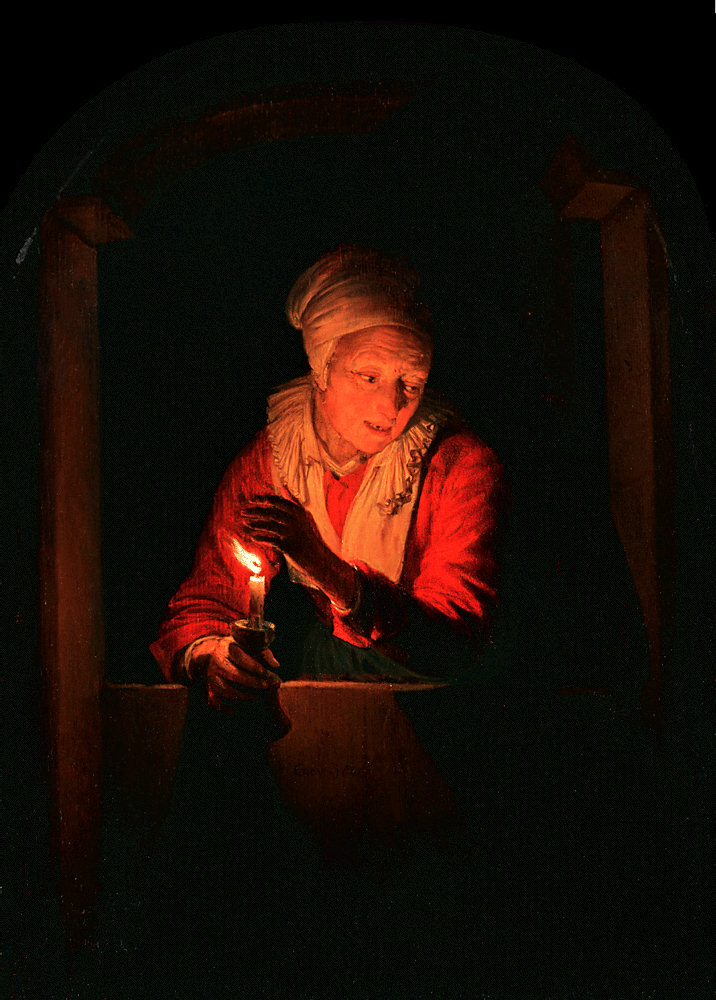Imagine this scene as the beginning of a fairytale. How would the story start? In a quaint village, nestled between rolling hills and ancient woods, there lived an elderly woman named Elda. Every night, she would sit by her window with a candle in hand, waiting for the magical hour when the moon would light up the night sky. Elda was the keeper of an age-old secret— a hidden path revealed only by the first glow of the moonlight, leading to a mystical forest where dreams and reality entwined. Little did she know, tonight was the night a young, curious wanderer would discover this secret and embark on an enchanting adventure that would change their life forever. 